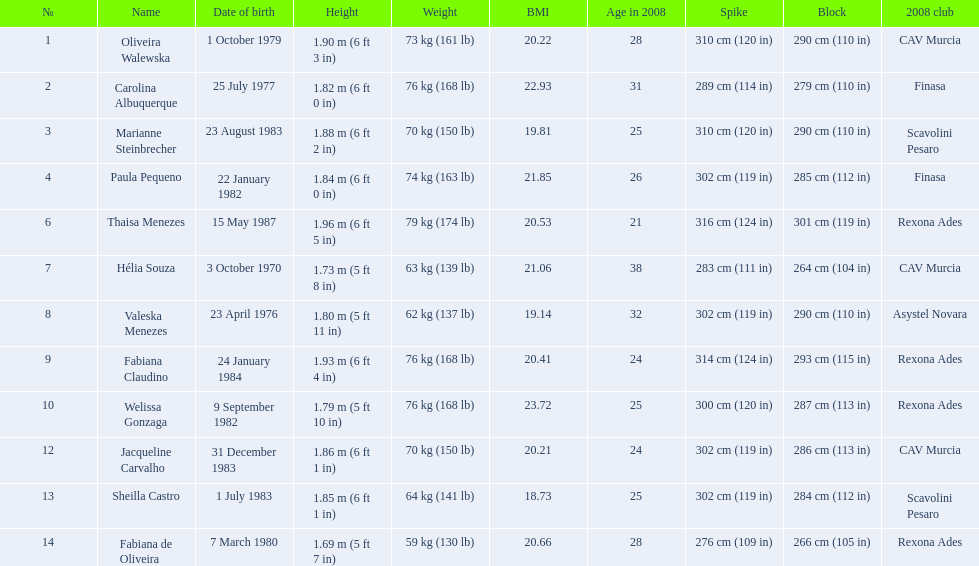What are the names of all the contestants? Oliveira Walewska, Carolina Albuquerque, Marianne Steinbrecher, Paula Pequeno, Thaisa Menezes, Hélia Souza, Valeska Menezes, Fabiana Claudino, Welissa Gonzaga, Jacqueline Carvalho, Sheilla Castro, Fabiana de Oliveira. What are the weight ranges of the contestants? 73 kg (161 lb), 76 kg (168 lb), 70 kg (150 lb), 74 kg (163 lb), 79 kg (174 lb), 63 kg (139 lb), 62 kg (137 lb), 76 kg (168 lb), 76 kg (168 lb), 70 kg (150 lb), 64 kg (141 lb), 59 kg (130 lb). Which player is heaviest. sheilla castro, fabiana de oliveira, or helia souza? Sheilla Castro. 